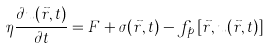Convert formula to latex. <formula><loc_0><loc_0><loc_500><loc_500>\eta \frac { \partial u ( \vec { r } , t ) } { \partial t } = F + \sigma ( \vec { r } , t ) - f _ { p } \left [ \vec { r } , u ( \vec { r } , t ) \right ]</formula> 